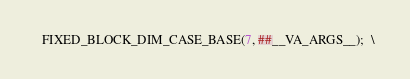Convert code to text. <code><loc_0><loc_0><loc_500><loc_500><_Cuda_>  FIXED_BLOCK_DIM_CASE_BASE(7, ##__VA_ARGS__);  \</code> 